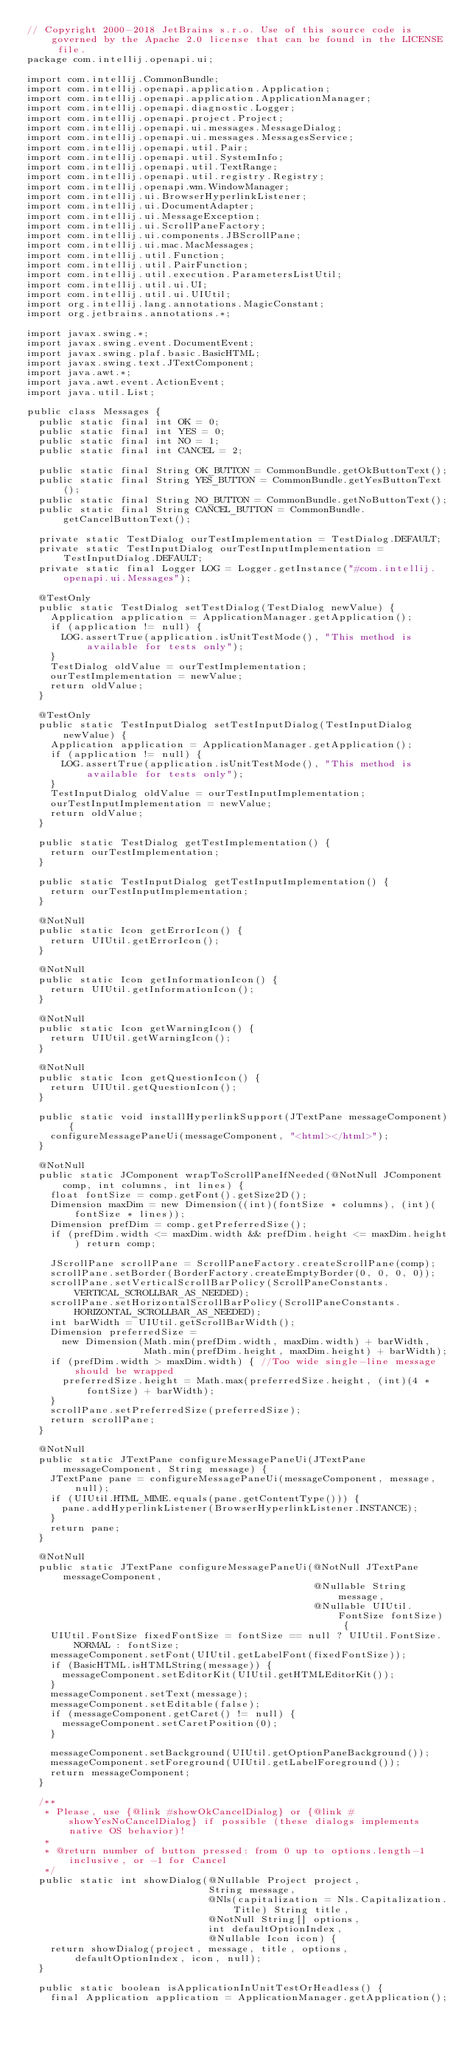<code> <loc_0><loc_0><loc_500><loc_500><_Java_>// Copyright 2000-2018 JetBrains s.r.o. Use of this source code is governed by the Apache 2.0 license that can be found in the LICENSE file.
package com.intellij.openapi.ui;

import com.intellij.CommonBundle;
import com.intellij.openapi.application.Application;
import com.intellij.openapi.application.ApplicationManager;
import com.intellij.openapi.diagnostic.Logger;
import com.intellij.openapi.project.Project;
import com.intellij.openapi.ui.messages.MessageDialog;
import com.intellij.openapi.ui.messages.MessagesService;
import com.intellij.openapi.util.Pair;
import com.intellij.openapi.util.SystemInfo;
import com.intellij.openapi.util.TextRange;
import com.intellij.openapi.util.registry.Registry;
import com.intellij.openapi.wm.WindowManager;
import com.intellij.ui.BrowserHyperlinkListener;
import com.intellij.ui.DocumentAdapter;
import com.intellij.ui.MessageException;
import com.intellij.ui.ScrollPaneFactory;
import com.intellij.ui.components.JBScrollPane;
import com.intellij.ui.mac.MacMessages;
import com.intellij.util.Function;
import com.intellij.util.PairFunction;
import com.intellij.util.execution.ParametersListUtil;
import com.intellij.util.ui.UI;
import com.intellij.util.ui.UIUtil;
import org.intellij.lang.annotations.MagicConstant;
import org.jetbrains.annotations.*;

import javax.swing.*;
import javax.swing.event.DocumentEvent;
import javax.swing.plaf.basic.BasicHTML;
import javax.swing.text.JTextComponent;
import java.awt.*;
import java.awt.event.ActionEvent;
import java.util.List;

public class Messages {
  public static final int OK = 0;
  public static final int YES = 0;
  public static final int NO = 1;
  public static final int CANCEL = 2;

  public static final String OK_BUTTON = CommonBundle.getOkButtonText();
  public static final String YES_BUTTON = CommonBundle.getYesButtonText();
  public static final String NO_BUTTON = CommonBundle.getNoButtonText();
  public static final String CANCEL_BUTTON = CommonBundle.getCancelButtonText();

  private static TestDialog ourTestImplementation = TestDialog.DEFAULT;
  private static TestInputDialog ourTestInputImplementation = TestInputDialog.DEFAULT;
  private static final Logger LOG = Logger.getInstance("#com.intellij.openapi.ui.Messages");

  @TestOnly
  public static TestDialog setTestDialog(TestDialog newValue) {
    Application application = ApplicationManager.getApplication();
    if (application != null) {
      LOG.assertTrue(application.isUnitTestMode(), "This method is available for tests only");
    }
    TestDialog oldValue = ourTestImplementation;
    ourTestImplementation = newValue;
    return oldValue;
  }

  @TestOnly
  public static TestInputDialog setTestInputDialog(TestInputDialog newValue) {
    Application application = ApplicationManager.getApplication();
    if (application != null) {
      LOG.assertTrue(application.isUnitTestMode(), "This method is available for tests only");
    }
    TestInputDialog oldValue = ourTestInputImplementation;
    ourTestInputImplementation = newValue;
    return oldValue;
  }

  public static TestDialog getTestImplementation() {
    return ourTestImplementation;
  }

  public static TestInputDialog getTestInputImplementation() {
    return ourTestInputImplementation;
  }

  @NotNull
  public static Icon getErrorIcon() {
    return UIUtil.getErrorIcon();
  }

  @NotNull
  public static Icon getInformationIcon() {
    return UIUtil.getInformationIcon();
  }

  @NotNull
  public static Icon getWarningIcon() {
    return UIUtil.getWarningIcon();
  }

  @NotNull
  public static Icon getQuestionIcon() {
    return UIUtil.getQuestionIcon();
  }

  public static void installHyperlinkSupport(JTextPane messageComponent) {
    configureMessagePaneUi(messageComponent, "<html></html>");
  }

  @NotNull
  public static JComponent wrapToScrollPaneIfNeeded(@NotNull JComponent comp, int columns, int lines) {
    float fontSize = comp.getFont().getSize2D();
    Dimension maxDim = new Dimension((int)(fontSize * columns), (int)(fontSize * lines));
    Dimension prefDim = comp.getPreferredSize();
    if (prefDim.width <= maxDim.width && prefDim.height <= maxDim.height) return comp;

    JScrollPane scrollPane = ScrollPaneFactory.createScrollPane(comp);
    scrollPane.setBorder(BorderFactory.createEmptyBorder(0, 0, 0, 0));
    scrollPane.setVerticalScrollBarPolicy(ScrollPaneConstants.VERTICAL_SCROLLBAR_AS_NEEDED);
    scrollPane.setHorizontalScrollBarPolicy(ScrollPaneConstants.HORIZONTAL_SCROLLBAR_AS_NEEDED);
    int barWidth = UIUtil.getScrollBarWidth();
    Dimension preferredSize =
      new Dimension(Math.min(prefDim.width, maxDim.width) + barWidth,
                    Math.min(prefDim.height, maxDim.height) + barWidth);
    if (prefDim.width > maxDim.width) { //Too wide single-line message should be wrapped
      preferredSize.height = Math.max(preferredSize.height, (int)(4 * fontSize) + barWidth);
    }
    scrollPane.setPreferredSize(preferredSize);
    return scrollPane;
  }

  @NotNull
  public static JTextPane configureMessagePaneUi(JTextPane messageComponent, String message) {
    JTextPane pane = configureMessagePaneUi(messageComponent, message, null);
    if (UIUtil.HTML_MIME.equals(pane.getContentType())) {
      pane.addHyperlinkListener(BrowserHyperlinkListener.INSTANCE);
    }
    return pane;
  }

  @NotNull
  public static JTextPane configureMessagePaneUi(@NotNull JTextPane messageComponent,
                                                 @Nullable String message,
                                                 @Nullable UIUtil.FontSize fontSize) {
    UIUtil.FontSize fixedFontSize = fontSize == null ? UIUtil.FontSize.NORMAL : fontSize;
    messageComponent.setFont(UIUtil.getLabelFont(fixedFontSize));
    if (BasicHTML.isHTMLString(message)) {
      messageComponent.setEditorKit(UIUtil.getHTMLEditorKit());
    }
    messageComponent.setText(message);
    messageComponent.setEditable(false);
    if (messageComponent.getCaret() != null) {
      messageComponent.setCaretPosition(0);
    }

    messageComponent.setBackground(UIUtil.getOptionPaneBackground());
    messageComponent.setForeground(UIUtil.getLabelForeground());
    return messageComponent;
  }

  /**
   * Please, use {@link #showOkCancelDialog} or {@link #showYesNoCancelDialog} if possible (these dialogs implements native OS behavior)!
   *
   * @return number of button pressed: from 0 up to options.length-1 inclusive, or -1 for Cancel
   */
  public static int showDialog(@Nullable Project project,
                               String message,
                               @Nls(capitalization = Nls.Capitalization.Title) String title,
                               @NotNull String[] options,
                               int defaultOptionIndex,
                               @Nullable Icon icon) {
    return showDialog(project, message, title, options, defaultOptionIndex, icon, null);
  }

  public static boolean isApplicationInUnitTestOrHeadless() {
    final Application application = ApplicationManager.getApplication();</code> 